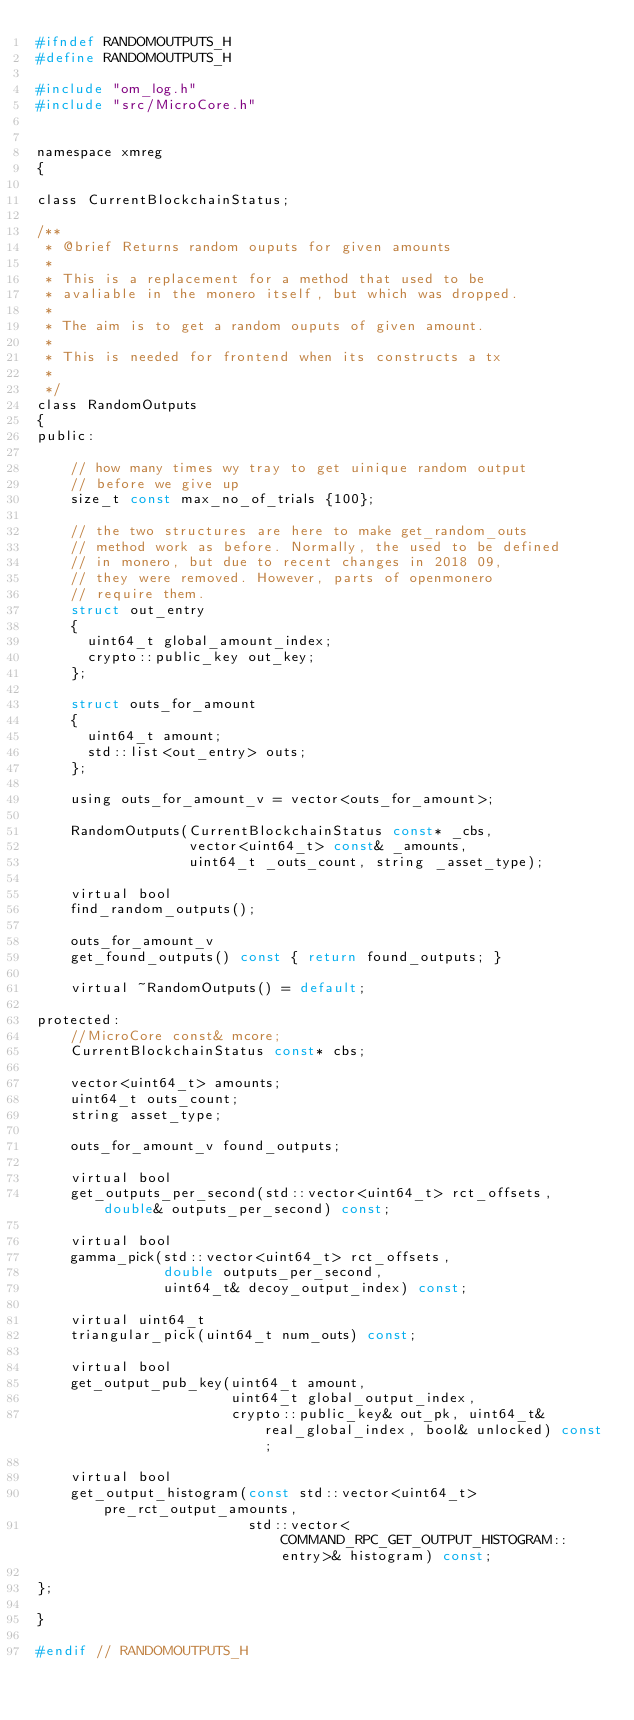<code> <loc_0><loc_0><loc_500><loc_500><_C_>#ifndef RANDOMOUTPUTS_H
#define RANDOMOUTPUTS_H

#include "om_log.h"
#include "src/MicroCore.h"


namespace xmreg
{

class CurrentBlockchainStatus;

/**
 * @brief Returns random ouputs for given amounts
 *
 * This is a replacement for a method that used to be
 * avaliable in the monero itself, but which was dropped.
 *
 * The aim is to get a random ouputs of given amount.
 *
 * This is needed for frontend when its constructs a tx
 *
 */
class RandomOutputs
{
public:

    // how many times wy tray to get uinique random output
    // before we give up
    size_t const max_no_of_trials {100};

    // the two structures are here to make get_random_outs
    // method work as before. Normally, the used to be defined
    // in monero, but due to recent changes in 2018 09,
    // they were removed. However, parts of openmonero
    // require them.
    struct out_entry
    {
      uint64_t global_amount_index;
      crypto::public_key out_key;
    };

    struct outs_for_amount
    {
      uint64_t amount;
      std::list<out_entry> outs;
    };

    using outs_for_amount_v = vector<outs_for_amount>;

    RandomOutputs(CurrentBlockchainStatus const* _cbs,
                  vector<uint64_t> const& _amounts,
                  uint64_t _outs_count, string _asset_type);

    virtual bool
    find_random_outputs();

    outs_for_amount_v
    get_found_outputs() const { return found_outputs; }

    virtual ~RandomOutputs() = default;

protected:
    //MicroCore const& mcore;
    CurrentBlockchainStatus const* cbs;

    vector<uint64_t> amounts;
    uint64_t outs_count;
    string asset_type;

    outs_for_amount_v found_outputs;

    virtual bool
    get_outputs_per_second(std::vector<uint64_t> rct_offsets, double& outputs_per_second) const;

    virtual bool
    gamma_pick(std::vector<uint64_t> rct_offsets,
               double outputs_per_second,
               uint64_t& decoy_output_index) const;

    virtual uint64_t
    triangular_pick(uint64_t num_outs) const;

    virtual bool
    get_output_pub_key(uint64_t amount,
                       uint64_t global_output_index,
                       crypto::public_key& out_pk, uint64_t& real_global_index, bool& unlocked) const;

    virtual bool
    get_output_histogram(const std::vector<uint64_t> pre_rct_output_amounts,
                         std::vector<COMMAND_RPC_GET_OUTPUT_HISTOGRAM::entry>& histogram) const;

};

}

#endif // RANDOMOUTPUTS_H
</code> 